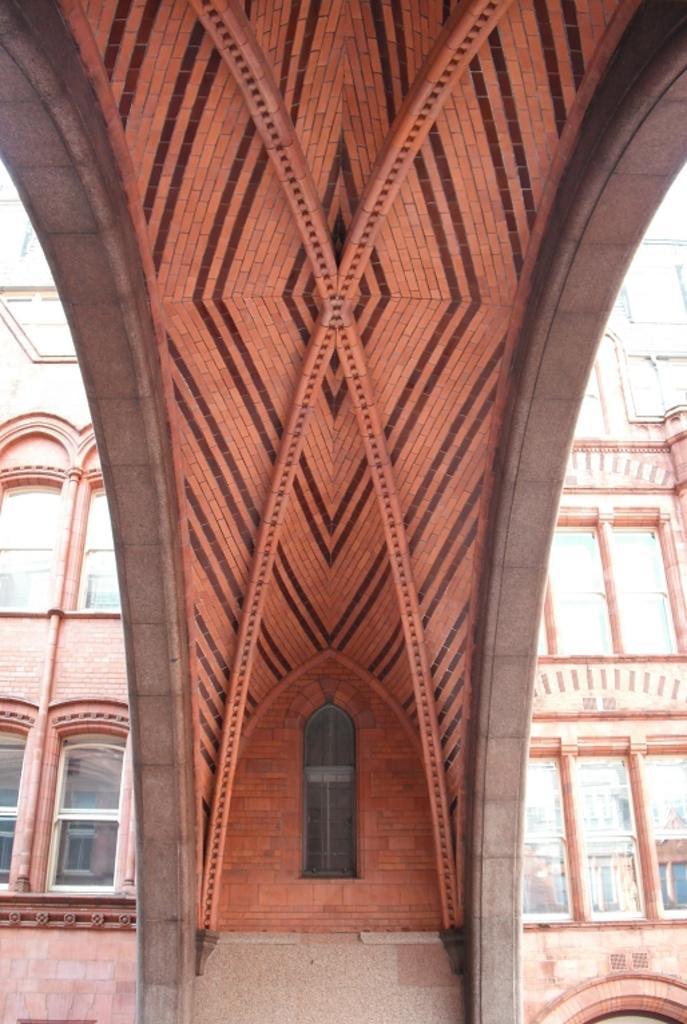Can you describe this image briefly? In this image we can see a building. On the building we can see glass windows. 